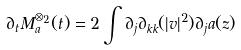<formula> <loc_0><loc_0><loc_500><loc_500>\partial _ { t } M _ { a } ^ { \otimes _ { 2 } } ( t ) = 2 \int \partial _ { j } \partial _ { k k } ( | v | ^ { 2 } ) \partial _ { j } a ( z )</formula> 